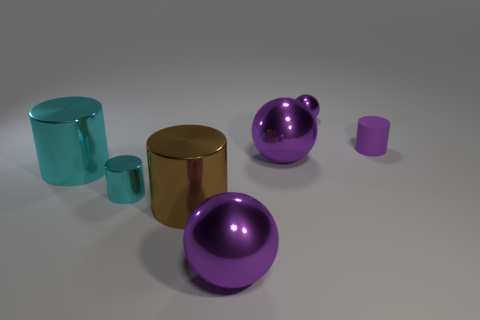Subtract all shiny cylinders. How many cylinders are left? 1 Add 2 yellow objects. How many objects exist? 9 Subtract all brown cylinders. How many cylinders are left? 3 Subtract 2 balls. How many balls are left? 1 Subtract all brown cylinders. Subtract all yellow blocks. How many cylinders are left? 3 Subtract all cyan spheres. How many cyan cylinders are left? 2 Subtract all purple cylinders. Subtract all tiny purple balls. How many objects are left? 5 Add 4 cyan cylinders. How many cyan cylinders are left? 6 Add 5 tiny purple rubber cylinders. How many tiny purple rubber cylinders exist? 6 Subtract 0 gray spheres. How many objects are left? 7 